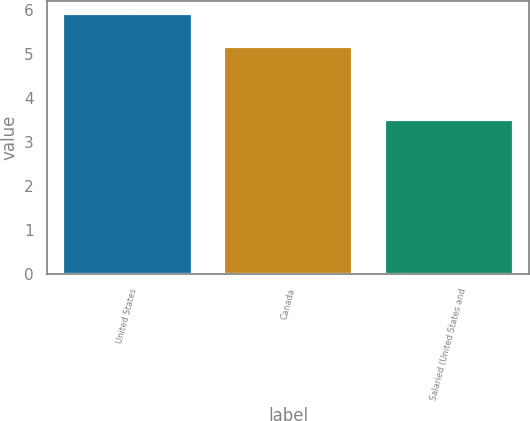<chart> <loc_0><loc_0><loc_500><loc_500><bar_chart><fcel>United States<fcel>Canada<fcel>Salaried (United States and<nl><fcel>5.9<fcel>5.15<fcel>3.5<nl></chart> 